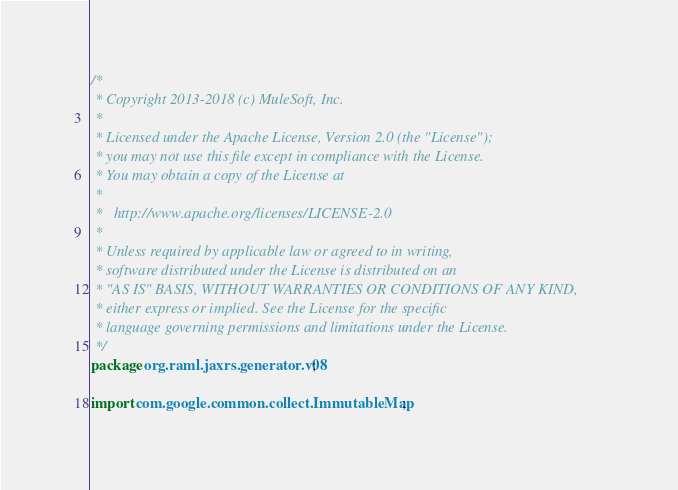<code> <loc_0><loc_0><loc_500><loc_500><_Java_>/*
 * Copyright 2013-2018 (c) MuleSoft, Inc.
 *
 * Licensed under the Apache License, Version 2.0 (the "License");
 * you may not use this file except in compliance with the License.
 * You may obtain a copy of the License at
 *
 *   http://www.apache.org/licenses/LICENSE-2.0
 *
 * Unless required by applicable law or agreed to in writing,
 * software distributed under the License is distributed on an
 * "AS IS" BASIS, WITHOUT WARRANTIES OR CONDITIONS OF ANY KIND,
 * either express or implied. See the License for the specific
 * language governing permissions and limitations under the License.
 */
package org.raml.jaxrs.generator.v08;

import com.google.common.collect.ImmutableMap;</code> 